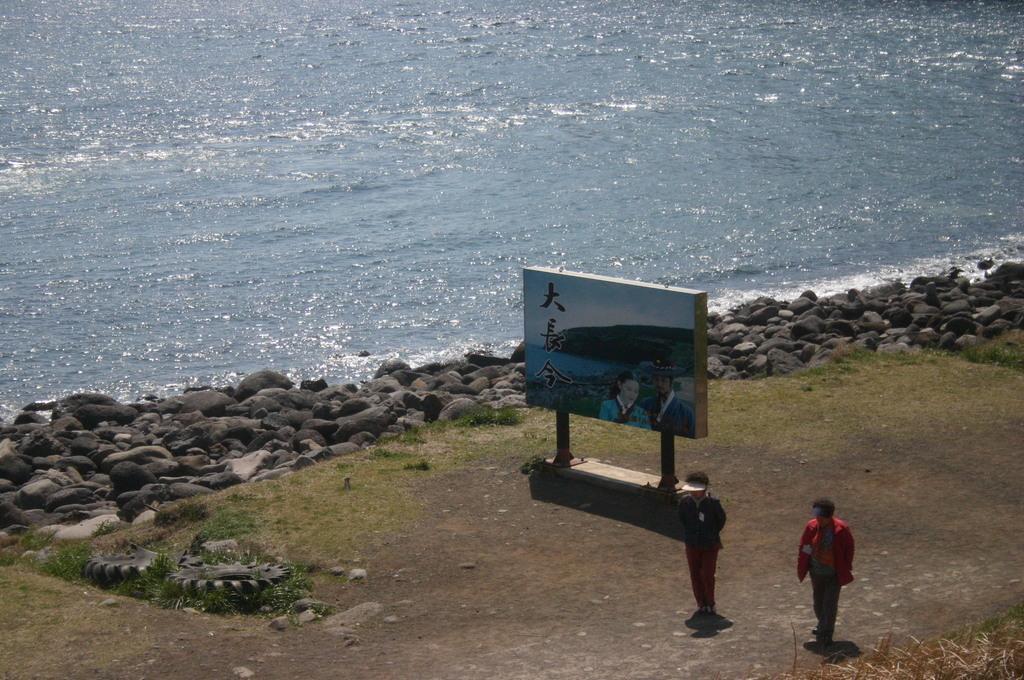Can you describe this image briefly? In this image we can see two people standing, a board with some text and image, there are some stones and water in the background. 